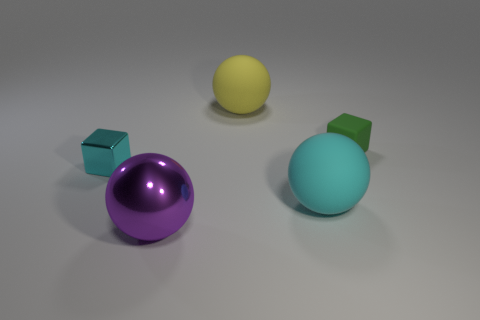How many other things are there of the same shape as the tiny green object?
Make the answer very short. 1. What color is the matte object that is in front of the tiny green thing?
Your response must be concise. Cyan. How many things are in front of the big sphere behind the cube that is right of the tiny cyan cube?
Provide a succinct answer. 4. There is a small block left of the small green rubber cube; how many big yellow things are right of it?
Your answer should be very brief. 1. What number of cyan objects are on the right side of the cyan cube?
Ensure brevity in your answer.  1. What number of other things are there of the same size as the rubber block?
Provide a succinct answer. 1. The cyan thing that is the same shape as the large purple thing is what size?
Ensure brevity in your answer.  Large. There is a green thing behind the big cyan matte object; what is its shape?
Your response must be concise. Cube. There is a tiny cube that is on the right side of the metallic ball that is in front of the small green block; what is its color?
Provide a short and direct response. Green. What number of objects are either big cyan rubber spheres in front of the green rubber block or purple balls?
Your answer should be very brief. 2. 